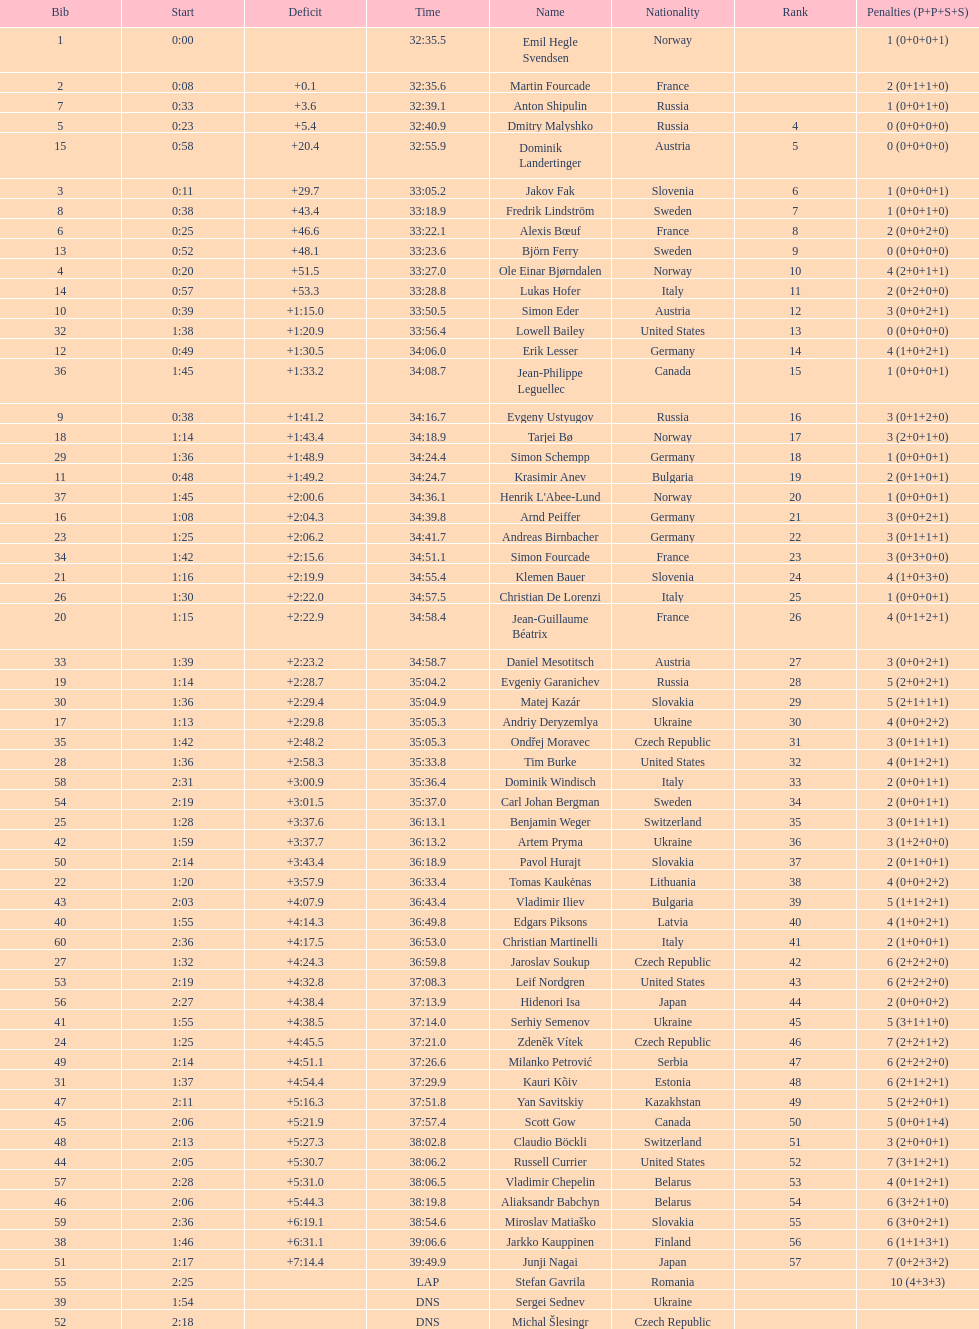Who is the top ranked runner of sweden? Fredrik Lindström. 